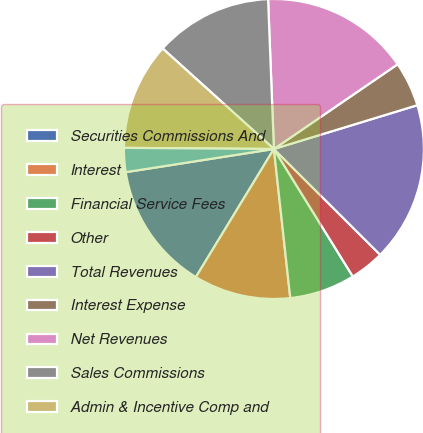Convert chart. <chart><loc_0><loc_0><loc_500><loc_500><pie_chart><fcel>Securities Commissions And<fcel>Interest<fcel>Financial Service Fees<fcel>Other<fcel>Total Revenues<fcel>Interest Expense<fcel>Net Revenues<fcel>Sales Commissions<fcel>Admin & Incentive Comp and<fcel>Communications and Information<nl><fcel>13.82%<fcel>10.45%<fcel>7.08%<fcel>3.71%<fcel>17.18%<fcel>4.84%<fcel>16.06%<fcel>12.69%<fcel>11.57%<fcel>2.59%<nl></chart> 